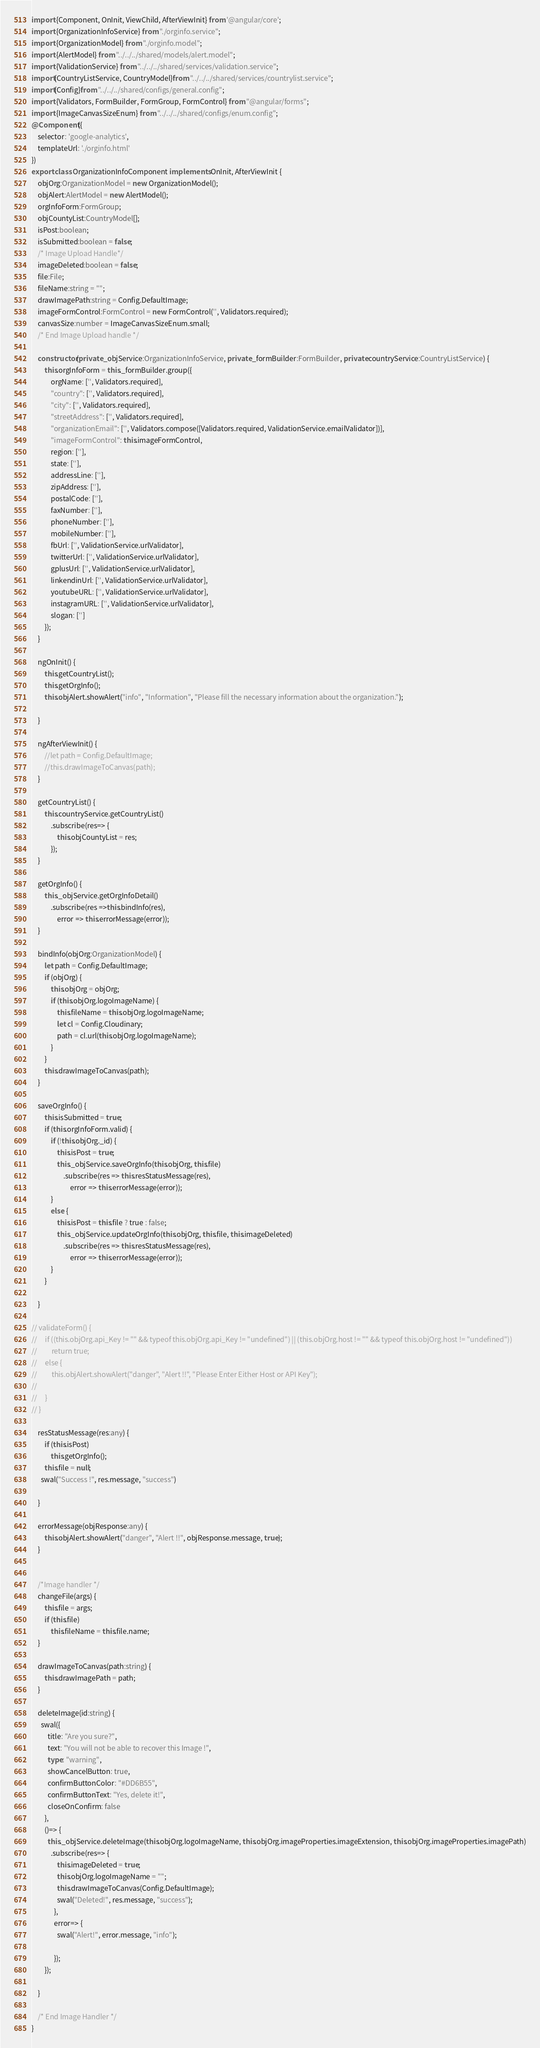Convert code to text. <code><loc_0><loc_0><loc_500><loc_500><_TypeScript_>import {Component, OnInit, ViewChild, AfterViewInit} from '@angular/core';
import {OrganizationInfoService} from "./orginfo.service";
import {OrganizationModel} from "./orginfo.model";
import {AlertModel} from "../../../shared/models/alert.model";
import {ValidationService} from "../../../shared/services/validation.service";
import{CountryListService, CountryModel}from "../../../shared/services/countrylist.service";
import{Config}from "../../../shared/configs/general.config";
import {Validators, FormBuilder, FormGroup, FormControl} from "@angular/forms";
import {ImageCanvasSizeEnum} from "../../../shared/configs/enum.config";
@Component({
    selector: 'google-analytics',
    templateUrl: './orginfo.html'
})
export class OrganizationInfoComponent implements OnInit, AfterViewInit {
    objOrg:OrganizationModel = new OrganizationModel();
    objAlert:AlertModel = new AlertModel();
    orgInfoForm:FormGroup;
    objCountyList:CountryModel[];
    isPost:boolean;
    isSubmitted:boolean = false;
    /* Image Upload Handle*/
    imageDeleted:boolean = false;
    file:File;
    fileName:string = "";
    drawImagePath:string = Config.DefaultImage;
    imageFormControl:FormControl = new FormControl('', Validators.required);
    canvasSize:number = ImageCanvasSizeEnum.small;
    /* End Image Upload handle */

    constructor(private _objService:OrganizationInfoService, private _formBuilder:FormBuilder, private countryService:CountryListService) {
        this.orgInfoForm = this._formBuilder.group({
            orgName: ['', Validators.required],
            "country": ['', Validators.required],
            "city": ['', Validators.required],
            "streetAddress": ['', Validators.required],
            "organizationEmail": ['', Validators.compose([Validators.required, ValidationService.emailValidator])],
            "imageFormControl": this.imageFormControl,
            region: [''],
            state: [''],
            addressLine: [''],
            zipAddress: [''],
            postalCode: [''],
            faxNumber: [''],
            phoneNumber: [''],
            mobileNumber: [''],
            fbUrl: ['', ValidationService.urlValidator],
            twitterUrl: ['', ValidationService.urlValidator],
            gplusUrl: ['', ValidationService.urlValidator],
            linkendinUrl: ['', ValidationService.urlValidator],
            youtubeURL: ['', ValidationService.urlValidator],
            instagramURL: ['', ValidationService.urlValidator],
            slogan: ['']
        });
    }

    ngOnInit() {
        this.getCountryList();
        this.getOrgInfo();
        this.objAlert.showAlert("info", "Information", "Please fill the necessary information about the organization.");

    }

    ngAfterViewInit() {
        //let path = Config.DefaultImage;
        //this.drawImageToCanvas(path);
    }

    getCountryList() {
        this.countryService.getCountryList()
            .subscribe(res=> {
                this.objCountyList = res;
            });
    }

    getOrgInfo() {
        this._objService.getOrgInfoDetail()
            .subscribe(res =>this.bindInfo(res),
                error => this.errorMessage(error));
    }

    bindInfo(objOrg:OrganizationModel) {
        let path = Config.DefaultImage;
        if (objOrg) {
            this.objOrg = objOrg;
            if (this.objOrg.logoImageName) {
                this.fileName = this.objOrg.logoImageName;
                let cl = Config.Cloudinary;
                path = cl.url(this.objOrg.logoImageName);
            }
        }
        this.drawImageToCanvas(path);
    }

    saveOrgInfo() {
        this.isSubmitted = true;
        if (this.orgInfoForm.valid) {
            if (!this.objOrg._id) {
                this.isPost = true;
                this._objService.saveOrgInfo(this.objOrg, this.file)
                    .subscribe(res => this.resStatusMessage(res),
                        error => this.errorMessage(error));
            }
            else {
                this.isPost = this.file ? true : false;
                this._objService.updateOrgInfo(this.objOrg, this.file, this.imageDeleted)
                    .subscribe(res => this.resStatusMessage(res),
                        error => this.errorMessage(error));
            }
        }

    }

// validateForm() {
//     if ((this.objOrg.api_Key != "" && typeof this.objOrg.api_Key != "undefined") || (this.objOrg.host != "" && typeof this.objOrg.host != "undefined"))
//         return true;
//     else {
//         this.objAlert.showAlert("danger", "Alert !!", "Please Enter Either Host or API Key");
//
//     }
// }

    resStatusMessage(res:any) {
        if (this.isPost)
            this.getOrgInfo();
        this.file = null;
      swal("Success !", res.message, "success")

    }

    errorMessage(objResponse:any) {
        this.objAlert.showAlert("danger", "Alert !!", objResponse.message, true);
    }


    /*Image handler */
    changeFile(args) {
        this.file = args;
        if (this.file)
            this.fileName = this.file.name;
    }

    drawImageToCanvas(path:string) {
        this.drawImagePath = path;
    }

    deleteImage(id:string) {
      swal({
          title: "Are you sure?",
          text: "You will not be able to recover this Image !",
          type: "warning",
          showCancelButton: true,
          confirmButtonColor: "#DD6B55",
          confirmButtonText: "Yes, delete it!",
          closeOnConfirm: false
        },
        ()=> {
          this._objService.deleteImage(this.objOrg.logoImageName, this.objOrg.imageProperties.imageExtension, this.objOrg.imageProperties.imagePath)
            .subscribe(res=> {
                this.imageDeleted = true;
                this.objOrg.logoImageName = "";
                this.drawImageToCanvas(Config.DefaultImage);
                swal("Deleted!", res.message, "success");
              },
              error=> {
                swal("Alert!", error.message, "info");

              });
        });

    }

    /* End Image Handler */
}

</code> 